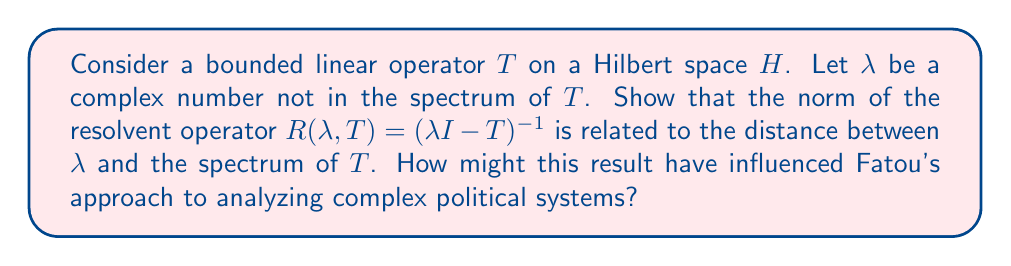Could you help me with this problem? Let's approach this step-by-step:

1) First, recall that the spectrum of $T$, denoted $\sigma(T)$, is the set of all complex numbers $\lambda$ for which $\lambda I - T$ is not invertible.

2) For any $\lambda \notin \sigma(T)$, the resolvent operator $R(\lambda, T) = (\lambda I - T)^{-1}$ exists.

3) Let's define $d(\lambda, \sigma(T))$ as the distance from $\lambda$ to the spectrum of $T$:

   $$d(\lambda, \sigma(T)) = \inf\{|\lambda - \mu|: \mu \in \sigma(T)\}$$

4) We can prove that:

   $$\|R(\lambda, T)\| \geq \frac{1}{d(\lambda, \sigma(T))}$$

5) To prove this, consider any $\mu \in \sigma(T)$. We have:

   $$\lambda - \mu = (\lambda I - T) - (\mu I - T)$$

6) Multiplying both sides by $R(\lambda, T)$ from the left:

   $$(\lambda - \mu)R(\lambda, T) = I - (\mu I - T)R(\lambda, T)$$

7) Taking norms and using the triangle inequality:

   $$|\lambda - \mu| \cdot \|R(\lambda, T)\| \geq 1 - \|(\mu I - T)R(\lambda, T)\|$$

8) Since $\mu I - T$ and $R(\lambda, T)$ commute:

   $$|\lambda - \mu| \cdot \|R(\lambda, T)\| \geq 1 - \|R(\lambda, T)\| \cdot \|\mu I - T\|$$

9) As this holds for all $\mu \in \sigma(T)$, we can take the infimum:

   $$d(\lambda, \sigma(T)) \cdot \|R(\lambda, T)\| \geq 1$$

10) This gives us the desired inequality:

    $$\|R(\lambda, T)\| \geq \frac{1}{d(\lambda, \sigma(T))}$$

This result shows that the norm of the resolvent grows as $\lambda$ approaches the spectrum of $T$. In a political context, Fatou might have used this concept to analyze the stability of political systems, where the spectrum could represent critical points of the system, and the resolvent norm could indicate the system's sensitivity to perturbations near these points.
Answer: $\|R(\lambda, T)\| \geq \frac{1}{d(\lambda, \sigma(T))}$ 